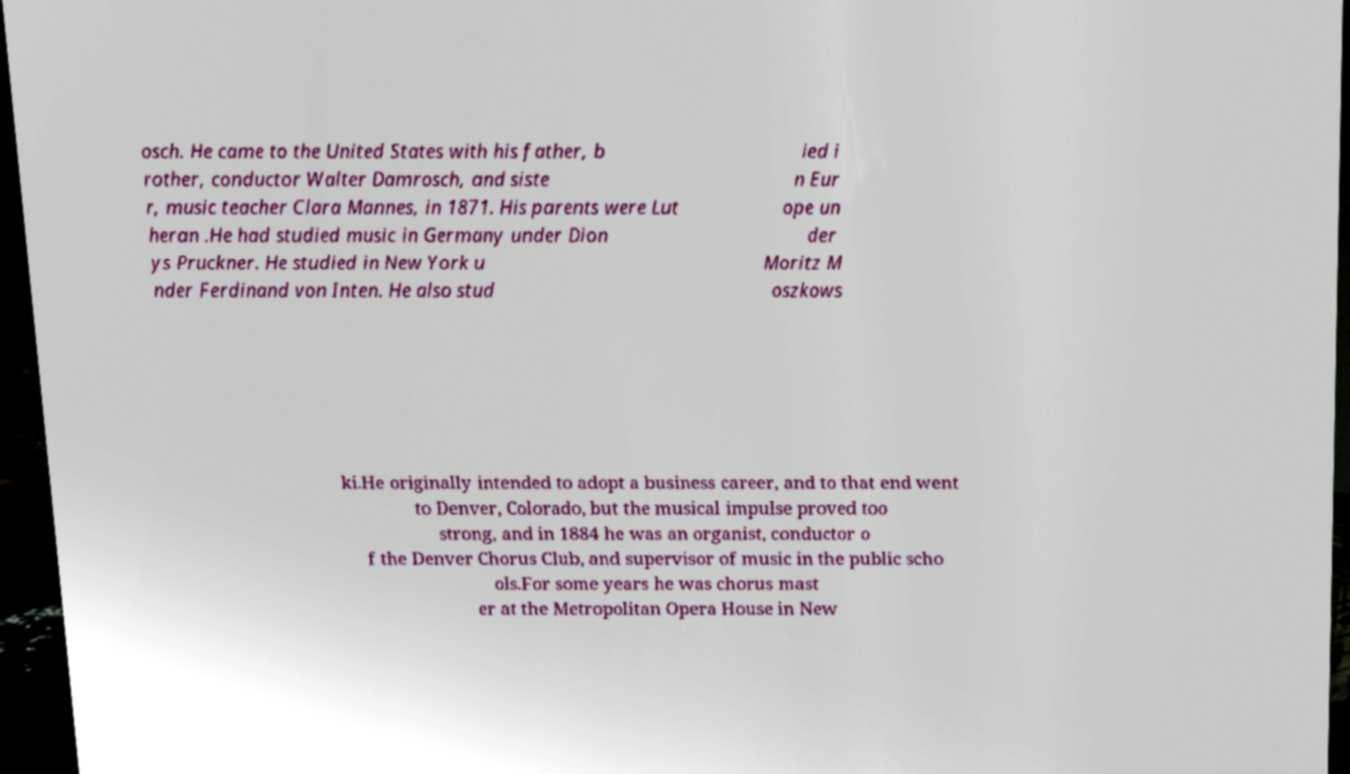Please read and relay the text visible in this image. What does it say? osch. He came to the United States with his father, b rother, conductor Walter Damrosch, and siste r, music teacher Clara Mannes, in 1871. His parents were Lut heran .He had studied music in Germany under Dion ys Pruckner. He studied in New York u nder Ferdinand von Inten. He also stud ied i n Eur ope un der Moritz M oszkows ki.He originally intended to adopt a business career, and to that end went to Denver, Colorado, but the musical impulse proved too strong, and in 1884 he was an organist, conductor o f the Denver Chorus Club, and supervisor of music in the public scho ols.For some years he was chorus mast er at the Metropolitan Opera House in New 